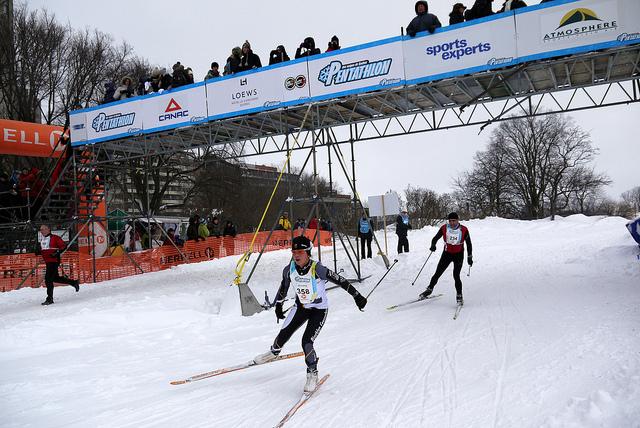What color is the ground?
Write a very short answer. White. Is it cold in the image?
Be succinct. Yes. How many people are skiing?
Give a very brief answer. 2. 